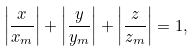Convert formula to latex. <formula><loc_0><loc_0><loc_500><loc_500>\left | { \frac { x } { x _ { m } } } \right | + \left | { \frac { y } { y _ { m } } } \right | + \left | { \frac { z } { z _ { m } } } \right | = 1 ,</formula> 